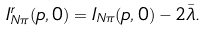<formula> <loc_0><loc_0><loc_500><loc_500>I _ { N \pi } ^ { r } ( p , 0 ) = I _ { N \pi } ( p , 0 ) - 2 \bar { \lambda } .</formula> 